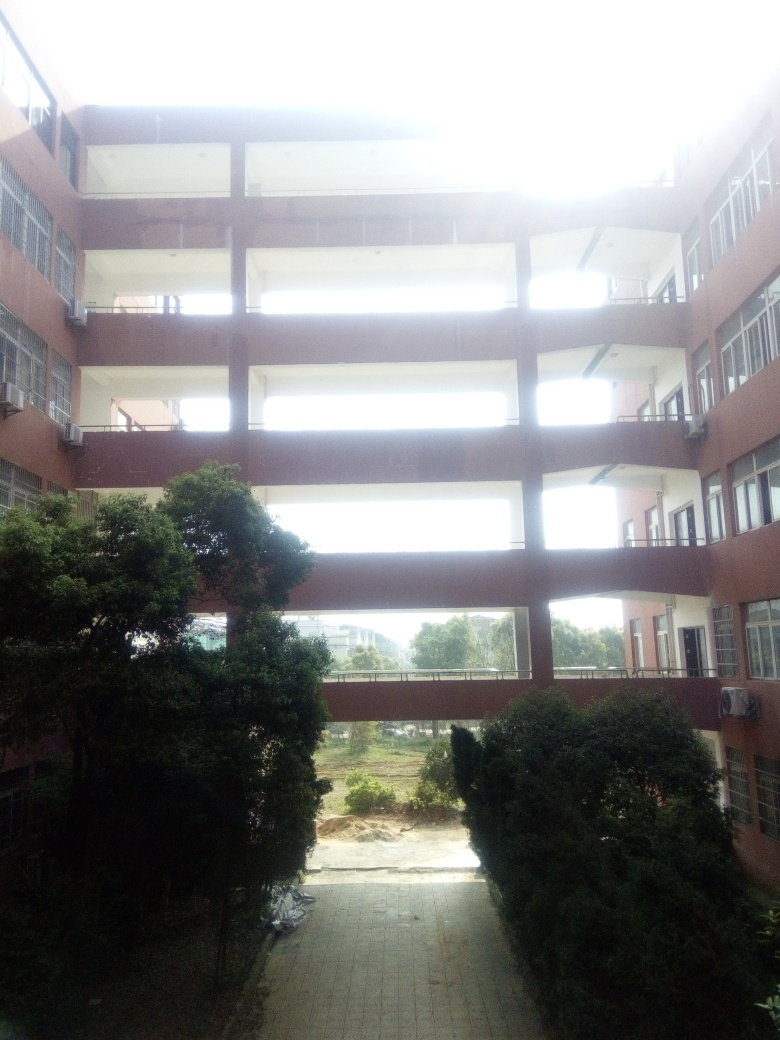What time of day does the lighting suggest, and what's the weather like? The brightness and lack of long shadows in the image suggest it was taken around midday when the sun is high in the sky. The sky appears to be overexposed, which makes it difficult to ascertain cloud cover, but the absence of shadows on the ground could indicate an overcast or hazy day. 